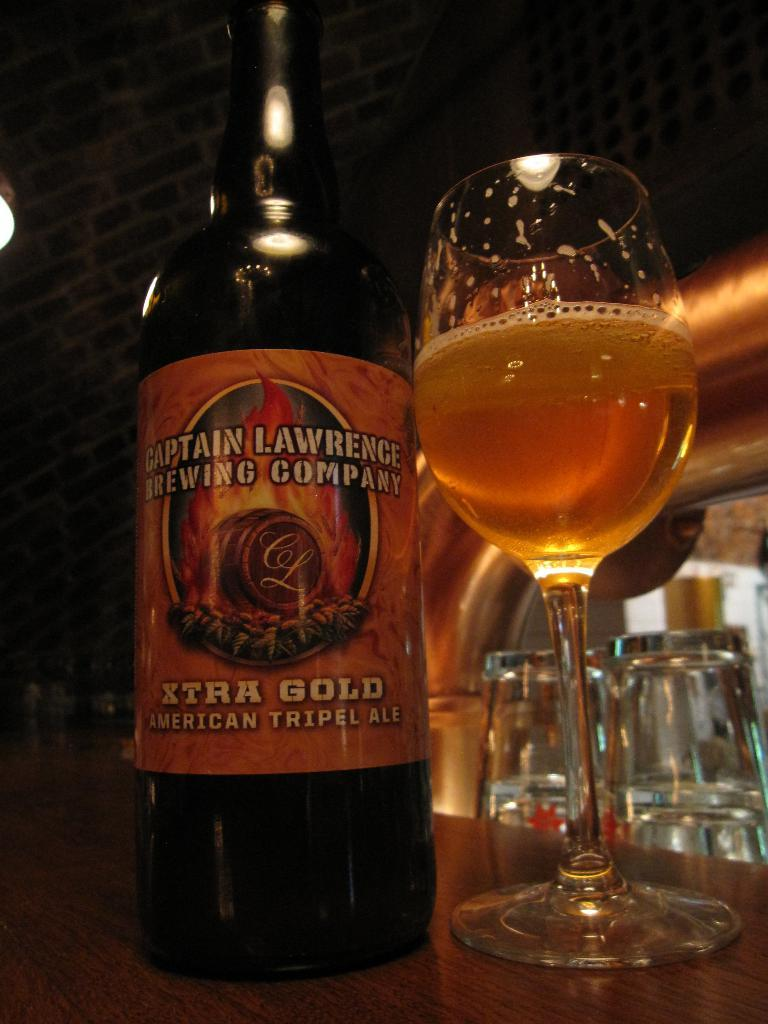<image>
Create a compact narrative representing the image presented. Captain Lawrence Brewing Company Xtra Gold American Tripel Ale Beer. 